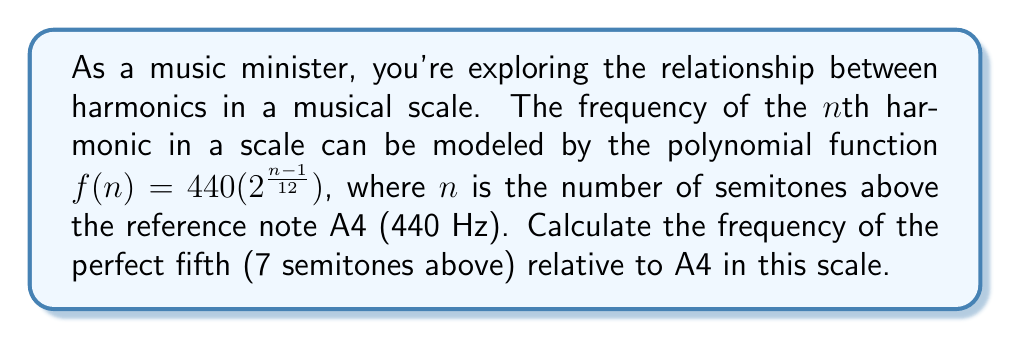Can you answer this question? To solve this problem, we'll follow these steps:

1) We're given the polynomial function for the frequency of the nth harmonic:
   $f(n) = 440(2^{\frac{n-1}{12}})$

2) We need to find the frequency for the perfect fifth, which is 7 semitones above the reference note. So, we'll substitute $n = 7$ into our function:

   $f(7) = 440(2^{\frac{7-1}{12}})$

3) Simplify the exponent:
   $f(7) = 440(2^{\frac{6}{12}})$

4) Simplify the fraction in the exponent:
   $f(7) = 440(2^{\frac{1}{2}})$

5) Calculate $2^{\frac{1}{2}}$:
   $2^{\frac{1}{2}} = \sqrt{2} \approx 1.4142$

6) Multiply:
   $f(7) = 440 * 1.4142 \approx 622.25$ Hz

Therefore, the frequency of the perfect fifth relative to A4 in this scale is approximately 622.25 Hz.
Answer: 622.25 Hz 